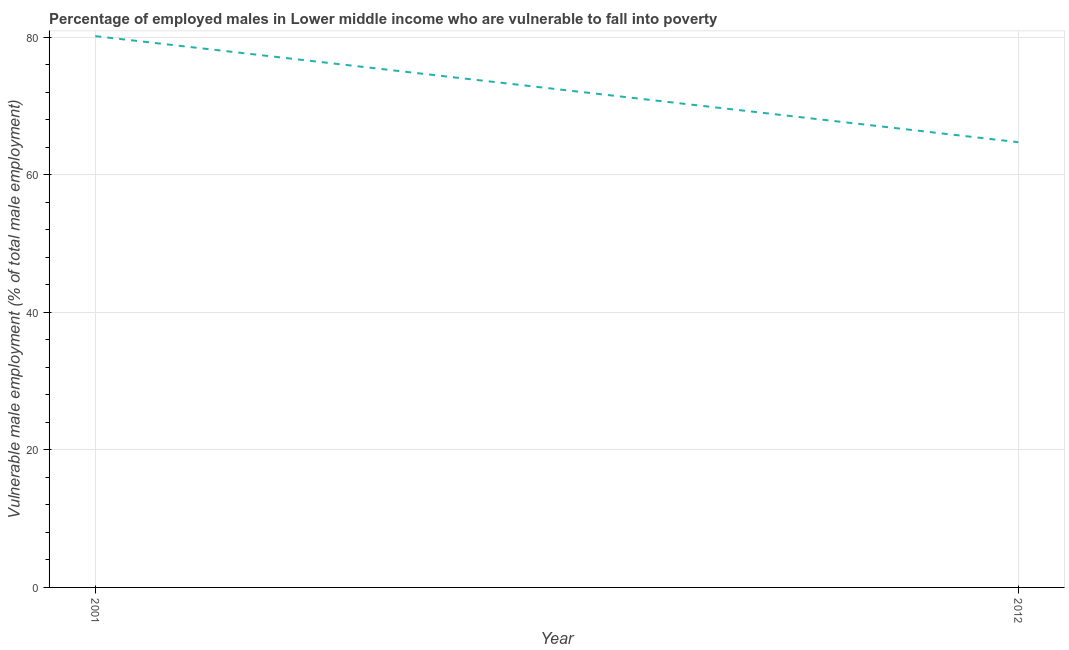What is the percentage of employed males who are vulnerable to fall into poverty in 2012?
Your answer should be compact. 64.74. Across all years, what is the maximum percentage of employed males who are vulnerable to fall into poverty?
Make the answer very short. 80.16. Across all years, what is the minimum percentage of employed males who are vulnerable to fall into poverty?
Make the answer very short. 64.74. In which year was the percentage of employed males who are vulnerable to fall into poverty minimum?
Your answer should be compact. 2012. What is the sum of the percentage of employed males who are vulnerable to fall into poverty?
Offer a very short reply. 144.9. What is the difference between the percentage of employed males who are vulnerable to fall into poverty in 2001 and 2012?
Ensure brevity in your answer.  15.42. What is the average percentage of employed males who are vulnerable to fall into poverty per year?
Your answer should be very brief. 72.45. What is the median percentage of employed males who are vulnerable to fall into poverty?
Keep it short and to the point. 72.45. Do a majority of the years between 2001 and 2012 (inclusive) have percentage of employed males who are vulnerable to fall into poverty greater than 16 %?
Offer a very short reply. Yes. What is the ratio of the percentage of employed males who are vulnerable to fall into poverty in 2001 to that in 2012?
Give a very brief answer. 1.24. Is the percentage of employed males who are vulnerable to fall into poverty in 2001 less than that in 2012?
Offer a very short reply. No. How many lines are there?
Your answer should be compact. 1. Are the values on the major ticks of Y-axis written in scientific E-notation?
Provide a succinct answer. No. What is the title of the graph?
Your response must be concise. Percentage of employed males in Lower middle income who are vulnerable to fall into poverty. What is the label or title of the X-axis?
Your answer should be very brief. Year. What is the label or title of the Y-axis?
Give a very brief answer. Vulnerable male employment (% of total male employment). What is the Vulnerable male employment (% of total male employment) of 2001?
Your response must be concise. 80.16. What is the Vulnerable male employment (% of total male employment) of 2012?
Offer a terse response. 64.74. What is the difference between the Vulnerable male employment (% of total male employment) in 2001 and 2012?
Make the answer very short. 15.42. What is the ratio of the Vulnerable male employment (% of total male employment) in 2001 to that in 2012?
Provide a short and direct response. 1.24. 